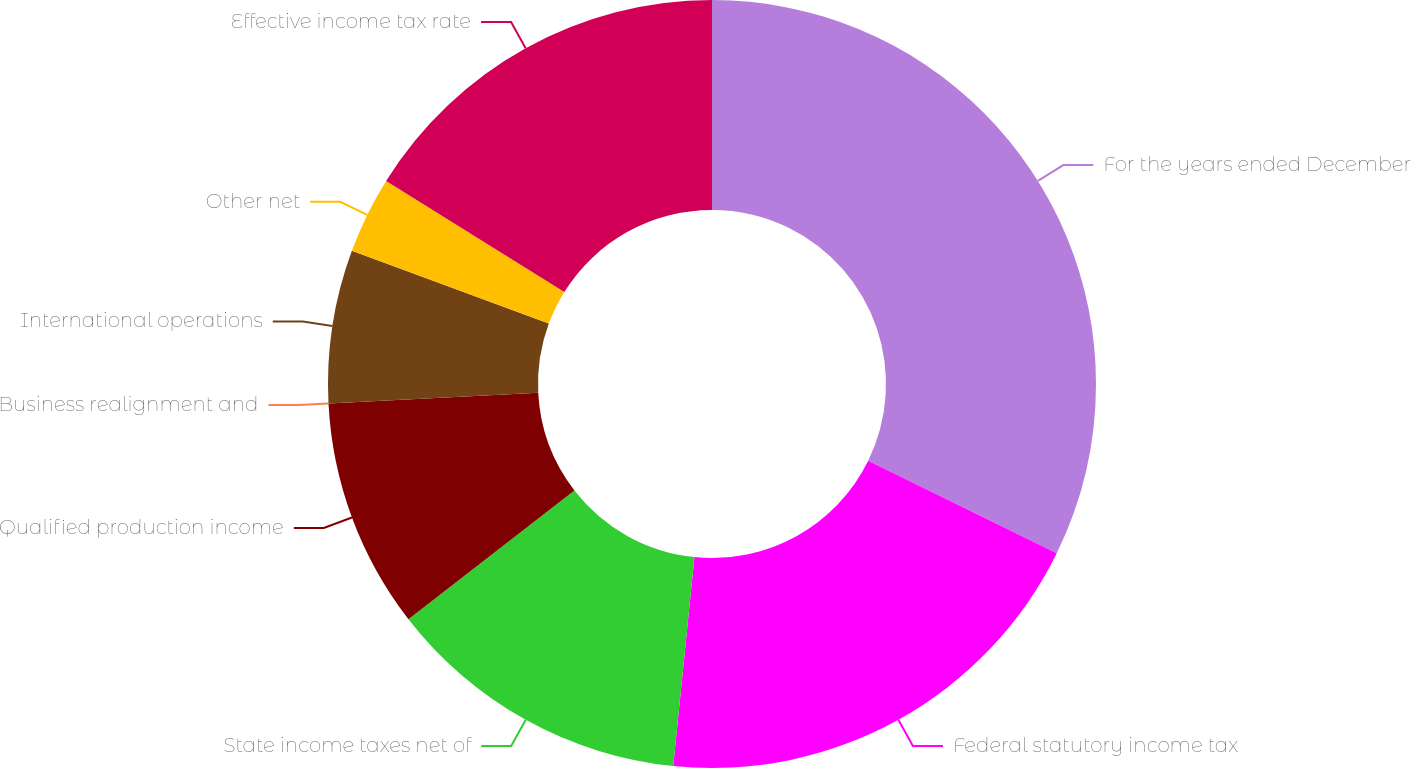<chart> <loc_0><loc_0><loc_500><loc_500><pie_chart><fcel>For the years ended December<fcel>Federal statutory income tax<fcel>State income taxes net of<fcel>Qualified production income<fcel>Business realignment and<fcel>International operations<fcel>Other net<fcel>Effective income tax rate<nl><fcel>32.26%<fcel>19.35%<fcel>12.9%<fcel>9.68%<fcel>0.0%<fcel>6.45%<fcel>3.23%<fcel>16.13%<nl></chart> 